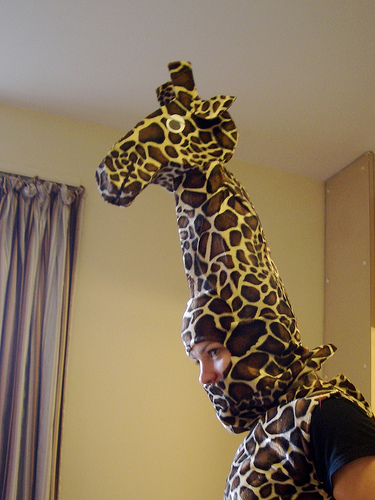<image>
Is there a giraffe on the person? Yes. Looking at the image, I can see the giraffe is positioned on top of the person, with the person providing support. 